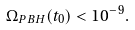Convert formula to latex. <formula><loc_0><loc_0><loc_500><loc_500>\Omega _ { P B H } ( t _ { 0 } ) < 1 0 ^ { - 9 } .</formula> 